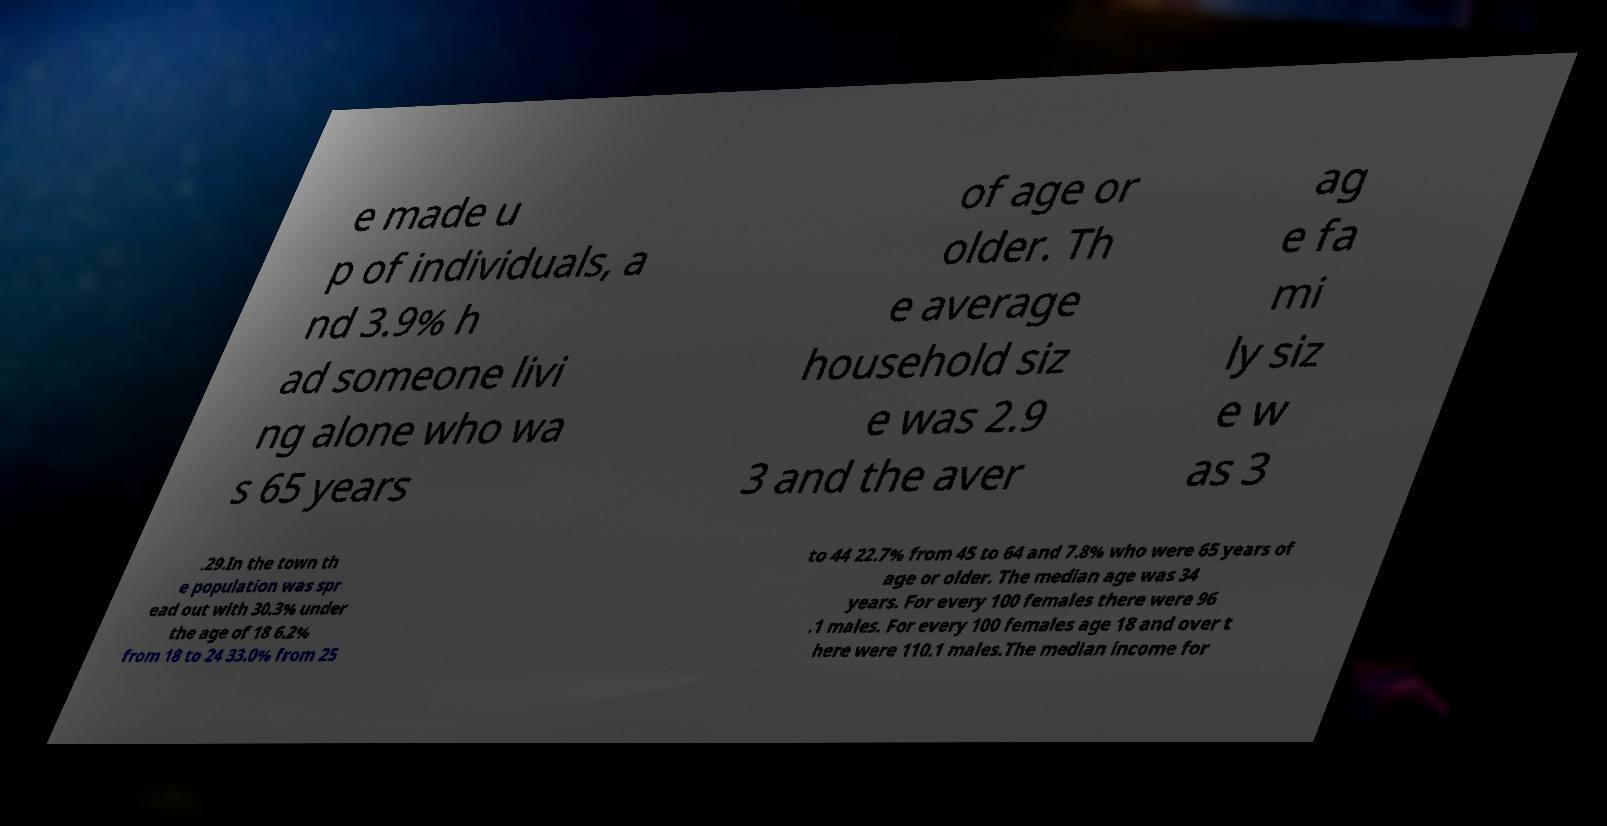Please identify and transcribe the text found in this image. e made u p of individuals, a nd 3.9% h ad someone livi ng alone who wa s 65 years of age or older. Th e average household siz e was 2.9 3 and the aver ag e fa mi ly siz e w as 3 .29.In the town th e population was spr ead out with 30.3% under the age of 18 6.2% from 18 to 24 33.0% from 25 to 44 22.7% from 45 to 64 and 7.8% who were 65 years of age or older. The median age was 34 years. For every 100 females there were 96 .1 males. For every 100 females age 18 and over t here were 110.1 males.The median income for 